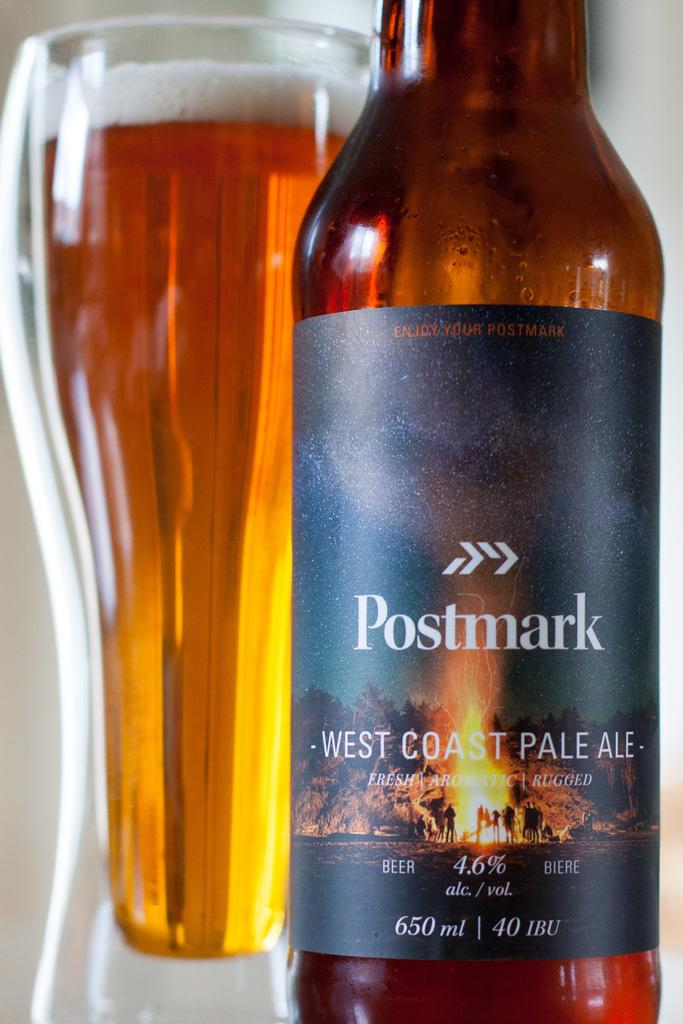<image>
Provide a brief description of the given image. A bottle of Postmark West Coast Pale Ale contains 650 ml of beer. 